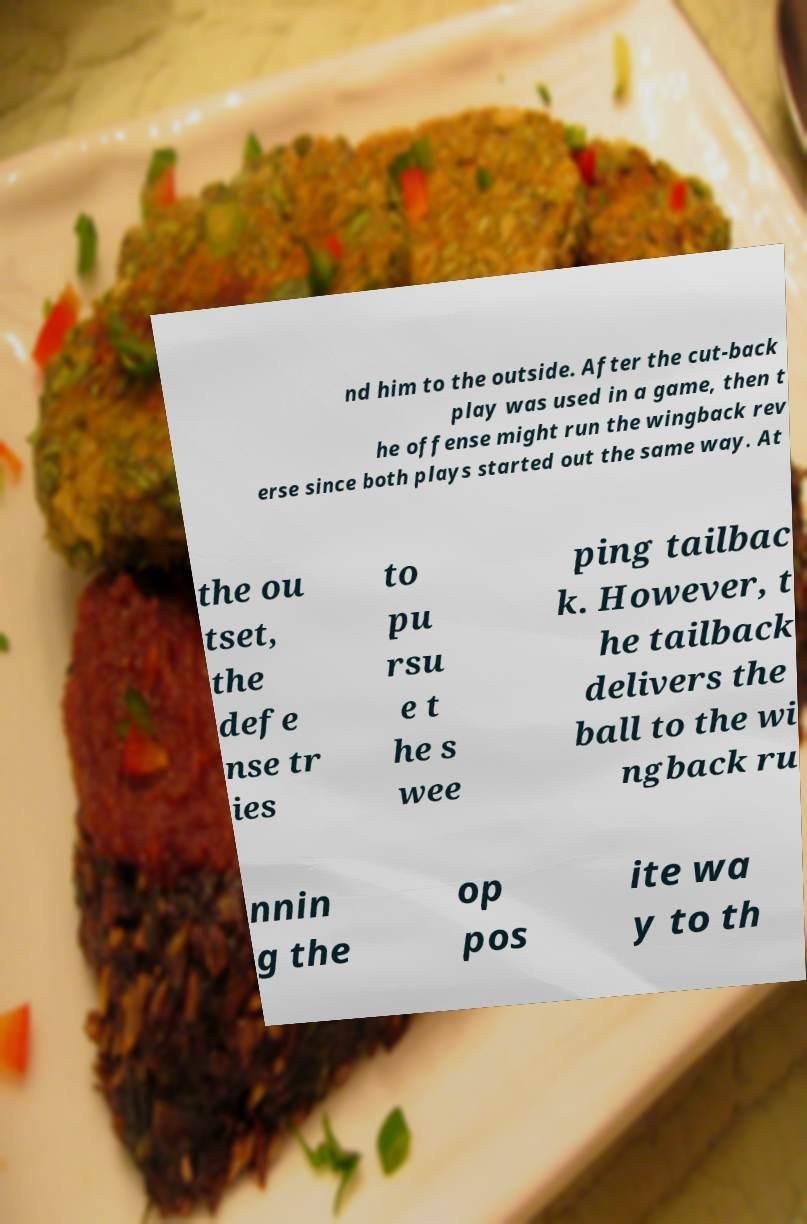I need the written content from this picture converted into text. Can you do that? nd him to the outside. After the cut-back play was used in a game, then t he offense might run the wingback rev erse since both plays started out the same way. At the ou tset, the defe nse tr ies to pu rsu e t he s wee ping tailbac k. However, t he tailback delivers the ball to the wi ngback ru nnin g the op pos ite wa y to th 